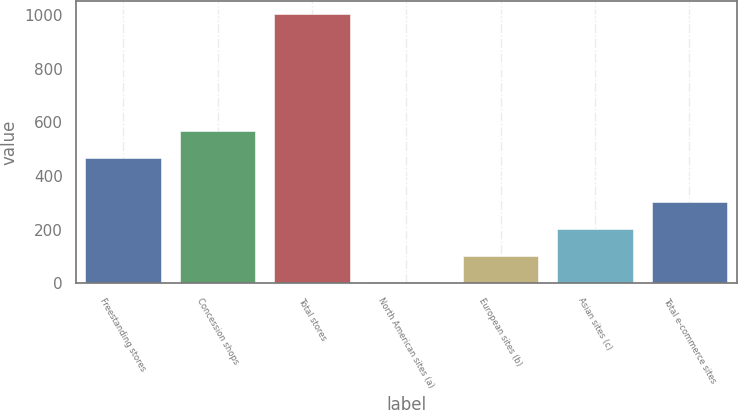Convert chart. <chart><loc_0><loc_0><loc_500><loc_500><bar_chart><fcel>Freestanding stores<fcel>Concession shops<fcel>Total stores<fcel>North American sites (a)<fcel>European sites (b)<fcel>Asian sites (c)<fcel>Total e-commerce sites<nl><fcel>466<fcel>565.9<fcel>1002<fcel>3<fcel>102.9<fcel>202.8<fcel>302.7<nl></chart> 